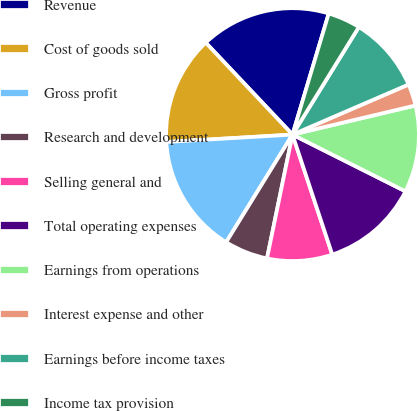<chart> <loc_0><loc_0><loc_500><loc_500><pie_chart><fcel>Revenue<fcel>Cost of goods sold<fcel>Gross profit<fcel>Research and development<fcel>Selling general and<fcel>Total operating expenses<fcel>Earnings from operations<fcel>Interest expense and other<fcel>Earnings before income taxes<fcel>Income tax provision<nl><fcel>16.67%<fcel>13.89%<fcel>15.28%<fcel>5.56%<fcel>8.33%<fcel>12.5%<fcel>11.11%<fcel>2.78%<fcel>9.72%<fcel>4.17%<nl></chart> 